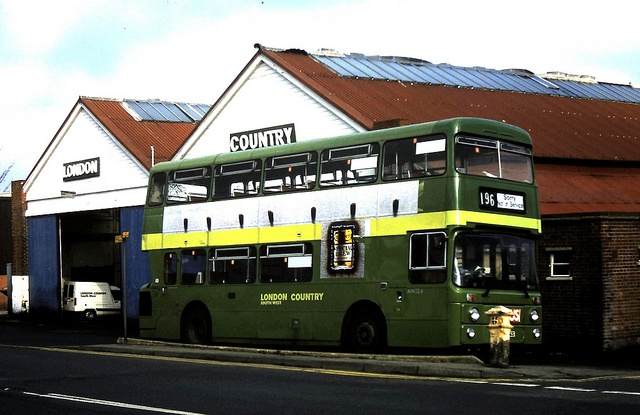Describe the objects in this image and their specific colors. I can see bus in white, black, gray, and yellow tones, truck in white, black, ivory, gray, and darkgray tones, and car in white, black, ivory, gray, and darkgray tones in this image. 